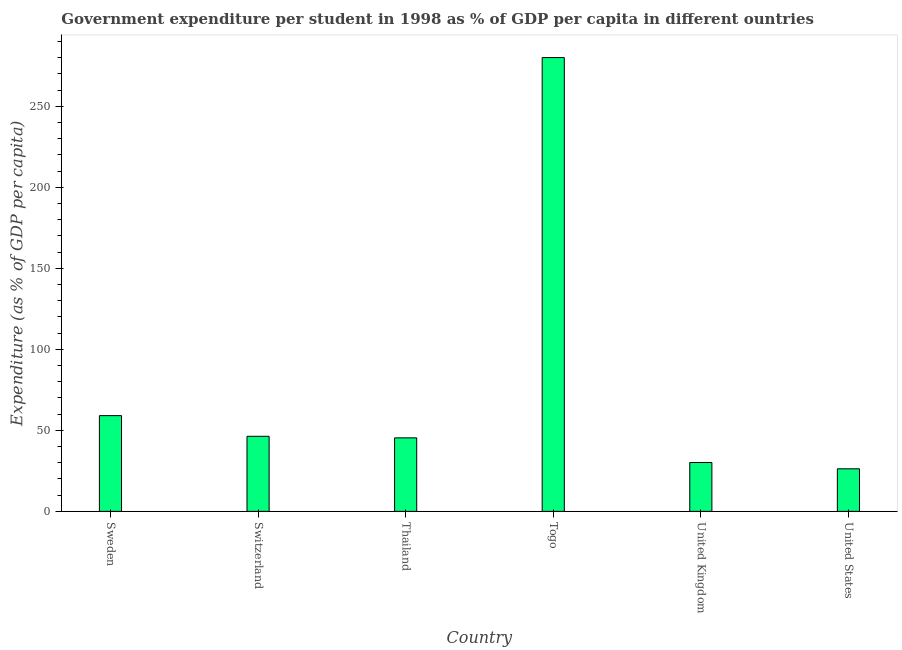Does the graph contain grids?
Your answer should be very brief. No. What is the title of the graph?
Provide a short and direct response. Government expenditure per student in 1998 as % of GDP per capita in different ountries. What is the label or title of the X-axis?
Offer a very short reply. Country. What is the label or title of the Y-axis?
Offer a terse response. Expenditure (as % of GDP per capita). What is the government expenditure per student in Togo?
Ensure brevity in your answer.  280.02. Across all countries, what is the maximum government expenditure per student?
Keep it short and to the point. 280.02. Across all countries, what is the minimum government expenditure per student?
Make the answer very short. 26.26. In which country was the government expenditure per student maximum?
Make the answer very short. Togo. What is the sum of the government expenditure per student?
Offer a very short reply. 487.16. What is the difference between the government expenditure per student in Switzerland and Togo?
Ensure brevity in your answer.  -233.7. What is the average government expenditure per student per country?
Make the answer very short. 81.19. What is the median government expenditure per student?
Offer a very short reply. 45.84. What is the ratio of the government expenditure per student in United Kingdom to that in United States?
Your answer should be compact. 1.15. Is the difference between the government expenditure per student in Sweden and Togo greater than the difference between any two countries?
Your answer should be very brief. No. What is the difference between the highest and the second highest government expenditure per student?
Give a very brief answer. 220.95. What is the difference between the highest and the lowest government expenditure per student?
Offer a very short reply. 253.76. How many bars are there?
Your answer should be very brief. 6. Are the values on the major ticks of Y-axis written in scientific E-notation?
Your response must be concise. No. What is the Expenditure (as % of GDP per capita) of Sweden?
Give a very brief answer. 59.07. What is the Expenditure (as % of GDP per capita) of Switzerland?
Offer a very short reply. 46.32. What is the Expenditure (as % of GDP per capita) in Thailand?
Provide a short and direct response. 45.36. What is the Expenditure (as % of GDP per capita) in Togo?
Your answer should be compact. 280.02. What is the Expenditure (as % of GDP per capita) of United Kingdom?
Your answer should be compact. 30.13. What is the Expenditure (as % of GDP per capita) of United States?
Keep it short and to the point. 26.26. What is the difference between the Expenditure (as % of GDP per capita) in Sweden and Switzerland?
Keep it short and to the point. 12.75. What is the difference between the Expenditure (as % of GDP per capita) in Sweden and Thailand?
Keep it short and to the point. 13.71. What is the difference between the Expenditure (as % of GDP per capita) in Sweden and Togo?
Your answer should be very brief. -220.95. What is the difference between the Expenditure (as % of GDP per capita) in Sweden and United Kingdom?
Offer a terse response. 28.94. What is the difference between the Expenditure (as % of GDP per capita) in Sweden and United States?
Your answer should be compact. 32.81. What is the difference between the Expenditure (as % of GDP per capita) in Switzerland and Thailand?
Make the answer very short. 0.96. What is the difference between the Expenditure (as % of GDP per capita) in Switzerland and Togo?
Your response must be concise. -233.7. What is the difference between the Expenditure (as % of GDP per capita) in Switzerland and United Kingdom?
Provide a succinct answer. 16.19. What is the difference between the Expenditure (as % of GDP per capita) in Switzerland and United States?
Keep it short and to the point. 20.06. What is the difference between the Expenditure (as % of GDP per capita) in Thailand and Togo?
Your answer should be compact. -234.66. What is the difference between the Expenditure (as % of GDP per capita) in Thailand and United Kingdom?
Your response must be concise. 15.22. What is the difference between the Expenditure (as % of GDP per capita) in Thailand and United States?
Your answer should be compact. 19.1. What is the difference between the Expenditure (as % of GDP per capita) in Togo and United Kingdom?
Your response must be concise. 249.89. What is the difference between the Expenditure (as % of GDP per capita) in Togo and United States?
Offer a terse response. 253.76. What is the difference between the Expenditure (as % of GDP per capita) in United Kingdom and United States?
Provide a succinct answer. 3.87. What is the ratio of the Expenditure (as % of GDP per capita) in Sweden to that in Switzerland?
Your response must be concise. 1.27. What is the ratio of the Expenditure (as % of GDP per capita) in Sweden to that in Thailand?
Ensure brevity in your answer.  1.3. What is the ratio of the Expenditure (as % of GDP per capita) in Sweden to that in Togo?
Your answer should be very brief. 0.21. What is the ratio of the Expenditure (as % of GDP per capita) in Sweden to that in United Kingdom?
Make the answer very short. 1.96. What is the ratio of the Expenditure (as % of GDP per capita) in Sweden to that in United States?
Make the answer very short. 2.25. What is the ratio of the Expenditure (as % of GDP per capita) in Switzerland to that in Thailand?
Make the answer very short. 1.02. What is the ratio of the Expenditure (as % of GDP per capita) in Switzerland to that in Togo?
Offer a very short reply. 0.17. What is the ratio of the Expenditure (as % of GDP per capita) in Switzerland to that in United Kingdom?
Make the answer very short. 1.54. What is the ratio of the Expenditure (as % of GDP per capita) in Switzerland to that in United States?
Keep it short and to the point. 1.76. What is the ratio of the Expenditure (as % of GDP per capita) in Thailand to that in Togo?
Offer a terse response. 0.16. What is the ratio of the Expenditure (as % of GDP per capita) in Thailand to that in United Kingdom?
Offer a terse response. 1.5. What is the ratio of the Expenditure (as % of GDP per capita) in Thailand to that in United States?
Your answer should be very brief. 1.73. What is the ratio of the Expenditure (as % of GDP per capita) in Togo to that in United Kingdom?
Keep it short and to the point. 9.29. What is the ratio of the Expenditure (as % of GDP per capita) in Togo to that in United States?
Offer a very short reply. 10.66. What is the ratio of the Expenditure (as % of GDP per capita) in United Kingdom to that in United States?
Provide a short and direct response. 1.15. 